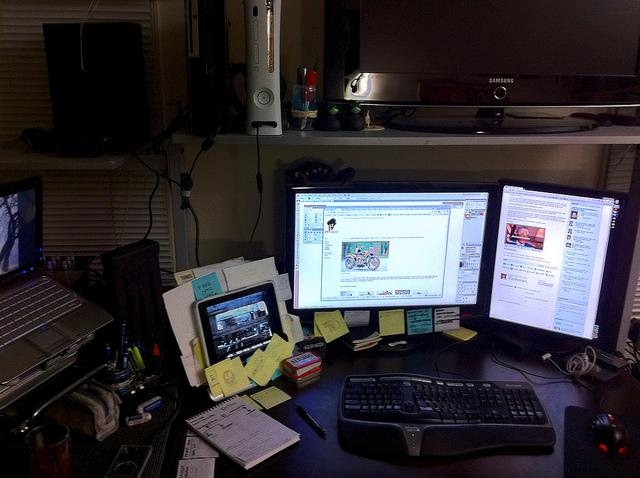What is the item called that has the red lights emanating from it? mouse 